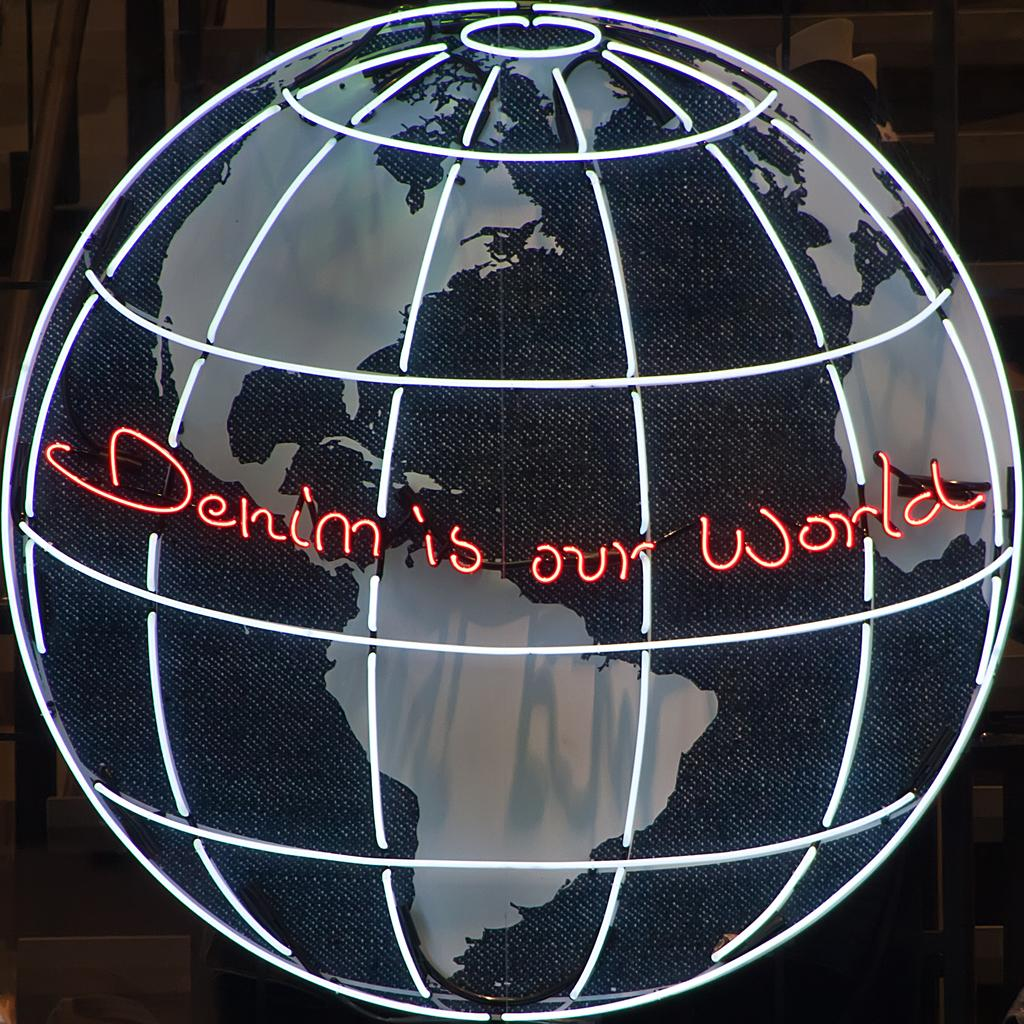What is the main object in the image? There is an LED sphere in the image. What is visible on the LED sphere? Something is written on the LED sphere. How would you describe the overall appearance of the image? The background of the image is dark. How many times has the LED sphere been folded in the image? The LED sphere cannot be folded, as it is a solid object. 